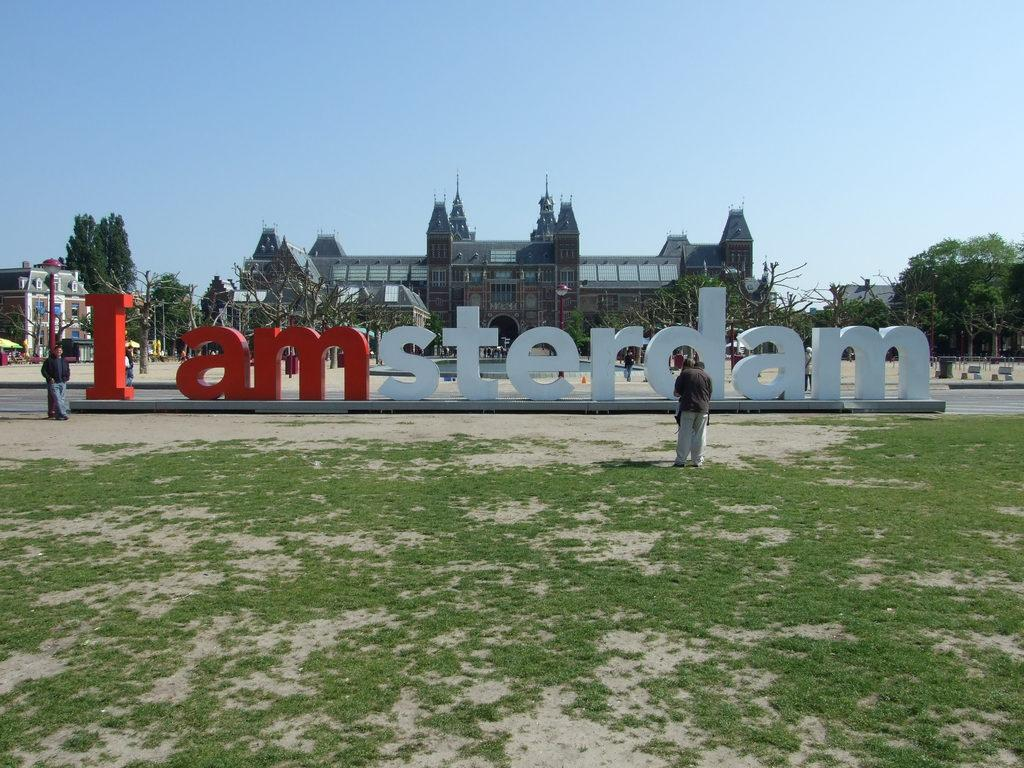What type of vegetation can be seen in the image? There is grass in the image. What educational or learning material is present in the image? There are boards with alphabets in the image. How many people are in the image? There are two persons in the image. What can be seen in the background of the image? There are trees, buildings, and the sky in the background of the image. What is the condition of the sky in the image? The sky is clear and visible in the background of the image. Who is the owner of the toothbrush in the image? There is no toothbrush present in the image. What type of operation is being performed by the persons in the image? There is no operation being performed by the persons in the image; they are simply standing near the boards with alphabets. 